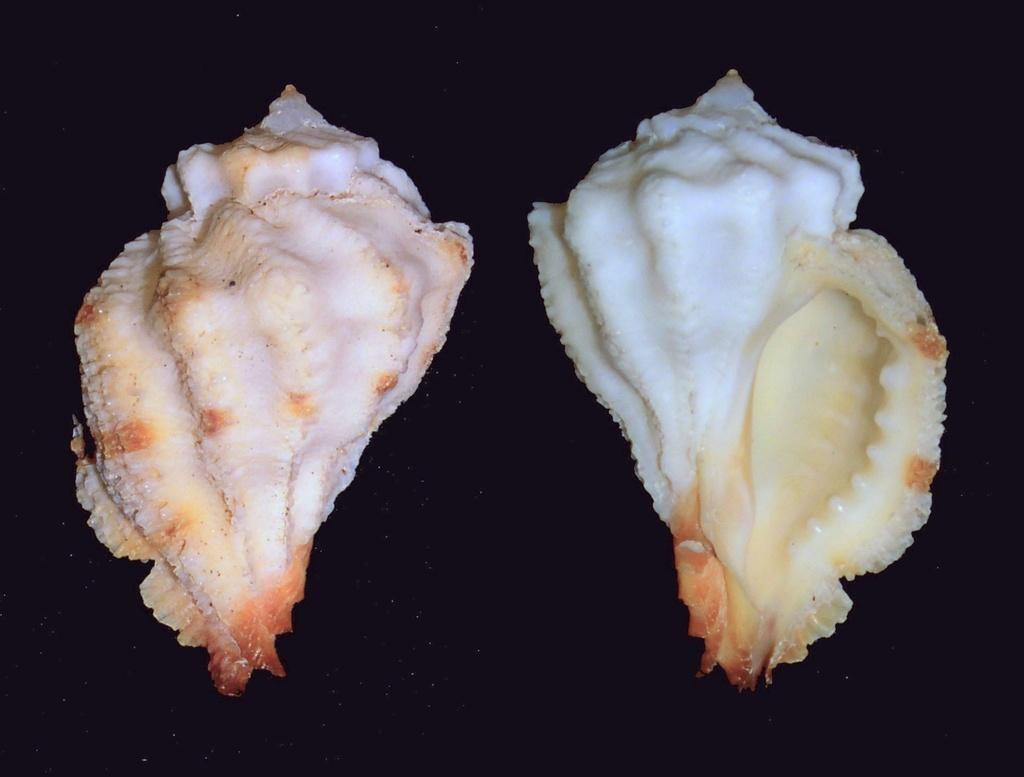In one or two sentences, can you explain what this image depicts? In the image we can see two seashells. 